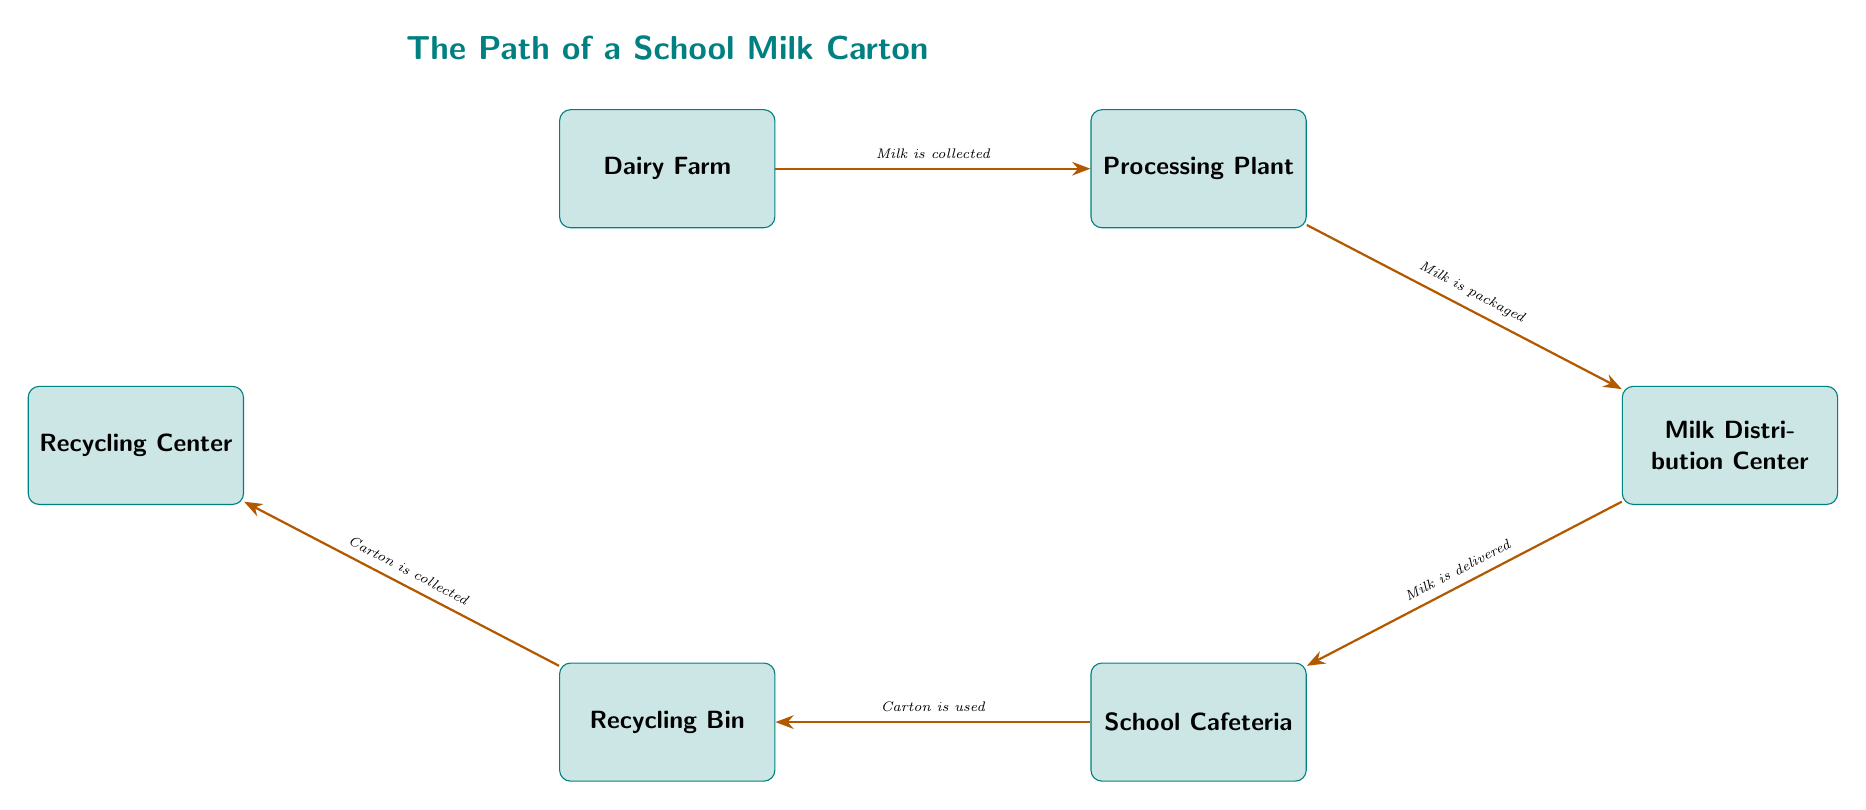What is the first step in the path of the milk carton? The diagram shows that the first step in the path of the milk carton is the 'Dairy Farm,' where the milk is initially collected.
Answer: Dairy Farm How many steps are there from the dairy farm to the recycling center? The diagram indicates there are five distinct steps: Dairy Farm, Processing Plant, Milk Distribution Center, School Cafeteria, and Recycling Bin leading to the Recycling Center.
Answer: Five What happens at the processing plant? At the processing plant, the milk is packaged for distribution, as indicated by the label on the arrow leading to the next step.
Answer: Milk is packaged Where does the milk carton go after the school cafeteria? The milk carton goes to the 'Recycling Bin' after it is used in the school cafeteria, as indicated by the arrow pointing left from the cafeteria.
Answer: Recycling Bin What is collected in the recycling center? The recycling center collects the carton, which is noted on the arrow coming from the recycling bin to the recycling center.
Answer: Carton What is the relationship between the processing plant and the milk distribution center? The relationship is that milk is packaged at the processing plant, which is then delivered to the milk distribution center, as shown by the arrow connecting these two nodes.
Answer: Milk is packaged How does the carton reach the recycling center? The carton reaches the recycling center by first being placed in the recycling bin, which is then collected and transferred to the recycling center, following the indicated path in the diagram.
Answer: Collected What is delivered to the school cafeteria? The diagram states that the 'Milk Distribution Center' delivers 'milk' to the school cafeteria, as described on the arrow connecting these two locations.
Answer: Milk What type of diagram is this? This diagram is a food chain that illustrates the path of a school milk carton, depicting the journey from the dairy farm to the recycling facility.
Answer: Food chain 